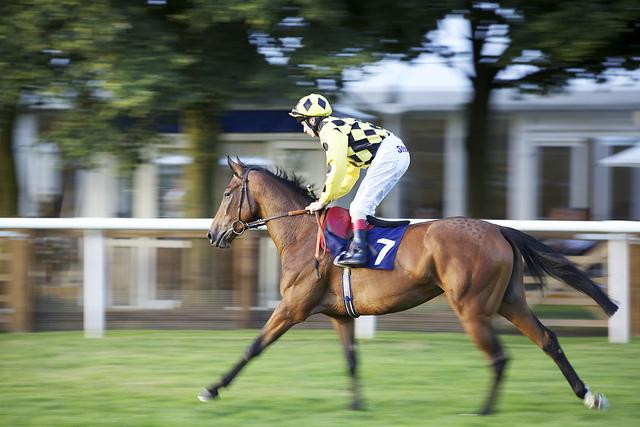What is the man on the horse called?
Concise answer only. Jockey. Is this person riding a dog?
Give a very brief answer. No. What is below the horse?
Concise answer only. Grass. 